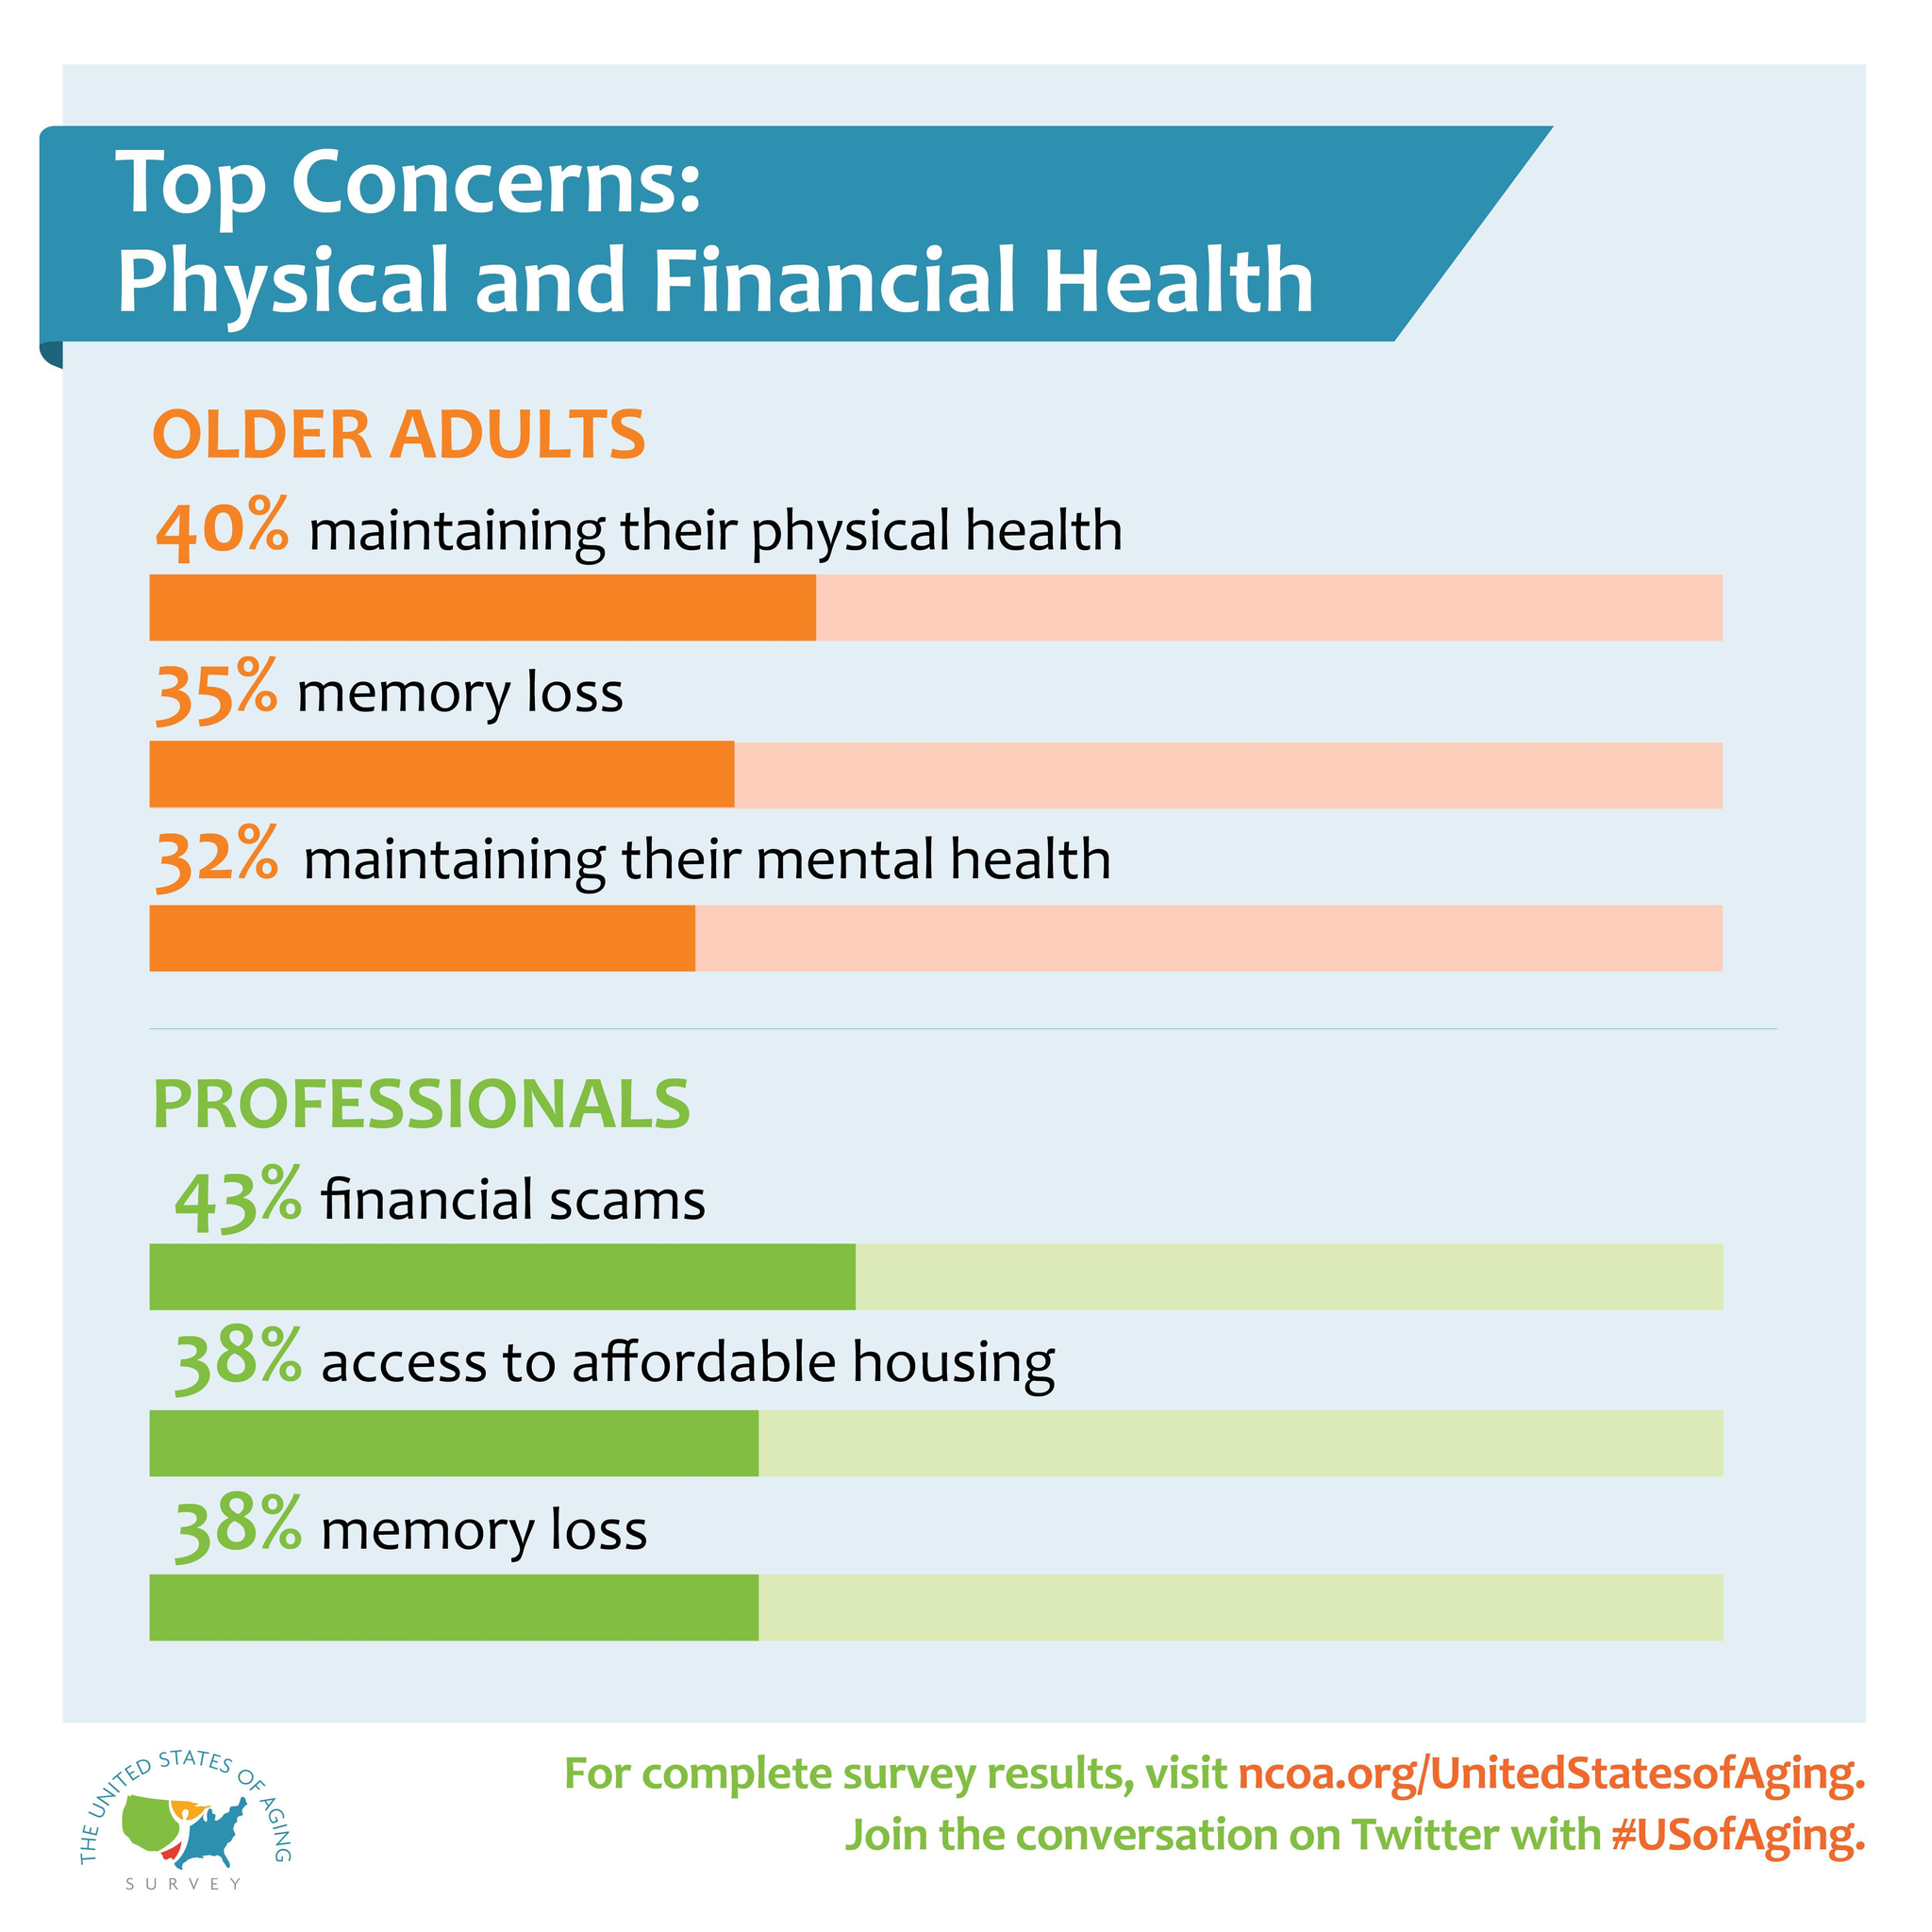What is the top concern of older adults?
Answer the question with a short phrase. maintaining their physical health 